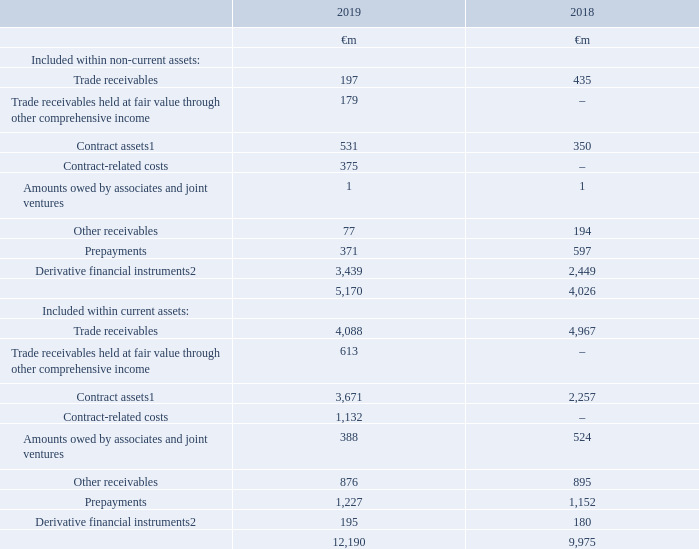14. Trade and other receivables
Trade and other receivables mainly consist of amounts owed to us by customers and amounts that we pay to our suppliers in advance. Derivative financial instruments with a positive market value are reported within this note as are contract assets, which represent an asset for accrued revenue in respect of goods or services delivered to customers for which a trade receivable does not yet exist.
Accounting policies
Trade receivables represent amounts owed by customers where the right to payment is conditional only on the passage of time. Trade receivables that are recovered in instalments from customers over an extended period are discounted at market rates and interest revenue is accredited over the expected repayment period. Other trade receivables do not carry any interest and are stated at their nominal value. When the Group establishes a practice of selling portfolios of receivables from time to time these portfolios are recorded at fair value through other comprehensive income; all other trade receivables are recorded at amortised cost
The carrying value of all trade receivables, contract assets and finance lease receivables recorded at amortised cost is reduced by allowances for lifetime estimated credit losses. Estimated future credit losses are first recorded on the initial recognition of a receivable and are based on the ageing of the receivable balances, historical experience and forward looking considerations. Individual balances are written off when management deems them not to be collectible.
Notes: 1 Previously described as accrued income in the year ended 31 March 2018
2 Items are measured at fair value and the valuation basis is level 2 classification, which comprises items where fair value is determined from inputs other than quoted prices that are observable for the asset or liability, either directly or indirectly
The Group’s trade receivables and contract assets are classified at amortised cost unless stated otherwise and are measured after allowances for future expected credit losses, see note 21 “Capital and financial risk management” for more information on credit risk.
The carrying amounts of trade and other receivables, which are measured at amortised cost, approximate their fair value and are predominantly non-interest bearing.
The Group’s contract-related costs comprise €1,433 million relating to costs incurred to obtain customer contracts and €74 million relating to costs incurred to fulfil customer contracts; an amortisation and impairment expense of €1,506 million was recognised in operating profit during the year.
In January and February 2019 €57 million and €70 million, respectively, of trade receivables were reclassified from amortised cost to fair value through other comprehensive income following changes to the Group’s business model under which the balances may be sold to a third party
The fair values of the derivative financial instruments are calculated by discounting the future cash flows to net present values using appropriate market interest rates and foreign currency rates prevailing at 31 March.
How much is the 2019 trade receivables included within non-current assets?
Answer scale should be: million. 197. How much is the 2018 trade receivables included within non-current assets?
Answer scale should be: million. 435. How much is the 2019 contract assets included within non-current assets?
Answer scale should be: million. 531. What is the average trade receivables included within non-current assets?
Answer scale should be: million. (197+435)/2
Answer: 316. What is the average prepayments included in non-current assets?
Answer scale should be: million. (371+597)/2
Answer: 484. Which year has higher trade receivables included within non-current assets? 435>197
Answer: 2018. 